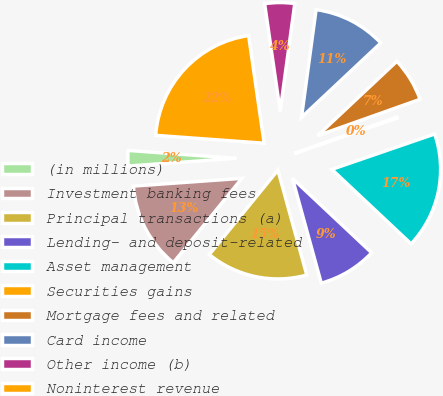<chart> <loc_0><loc_0><loc_500><loc_500><pie_chart><fcel>(in millions)<fcel>Investment banking fees<fcel>Principal transactions (a)<fcel>Lending- and deposit-related<fcel>Asset management<fcel>Securities gains<fcel>Mortgage fees and related<fcel>Card income<fcel>Other income (b)<fcel>Noninterest revenue<nl><fcel>2.29%<fcel>13.0%<fcel>15.14%<fcel>8.72%<fcel>17.28%<fcel>0.15%<fcel>6.57%<fcel>10.86%<fcel>4.43%<fcel>21.56%<nl></chart> 